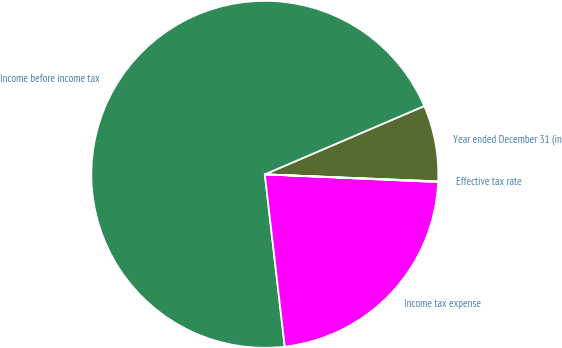<chart> <loc_0><loc_0><loc_500><loc_500><pie_chart><fcel>Year ended December 31 (in<fcel>Income before income tax<fcel>Income tax expense<fcel>Effective tax rate<nl><fcel>7.09%<fcel>70.38%<fcel>22.46%<fcel>0.06%<nl></chart> 